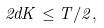Convert formula to latex. <formula><loc_0><loc_0><loc_500><loc_500>2 d K \leq T / 2 ,</formula> 